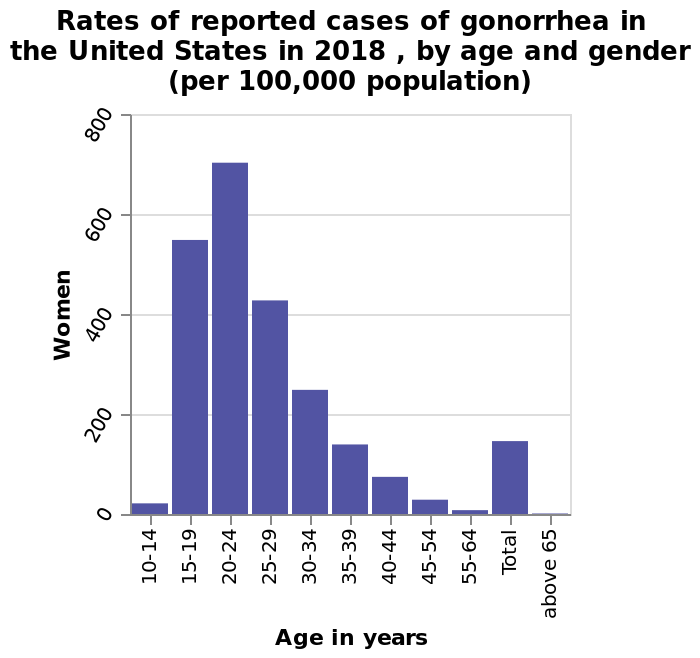<image>
In which year was the data for the bar chart collected?  The data for the bar chart was collected in 2018. please summary the statistics and relations of the chart I can see that 15- 29 year old have the greatest risk of catching gonnereha. 